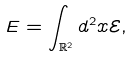Convert formula to latex. <formula><loc_0><loc_0><loc_500><loc_500>E = \int _ { \mathbb { R } ^ { 2 } } d ^ { 2 } x \mathcal { E } ,</formula> 